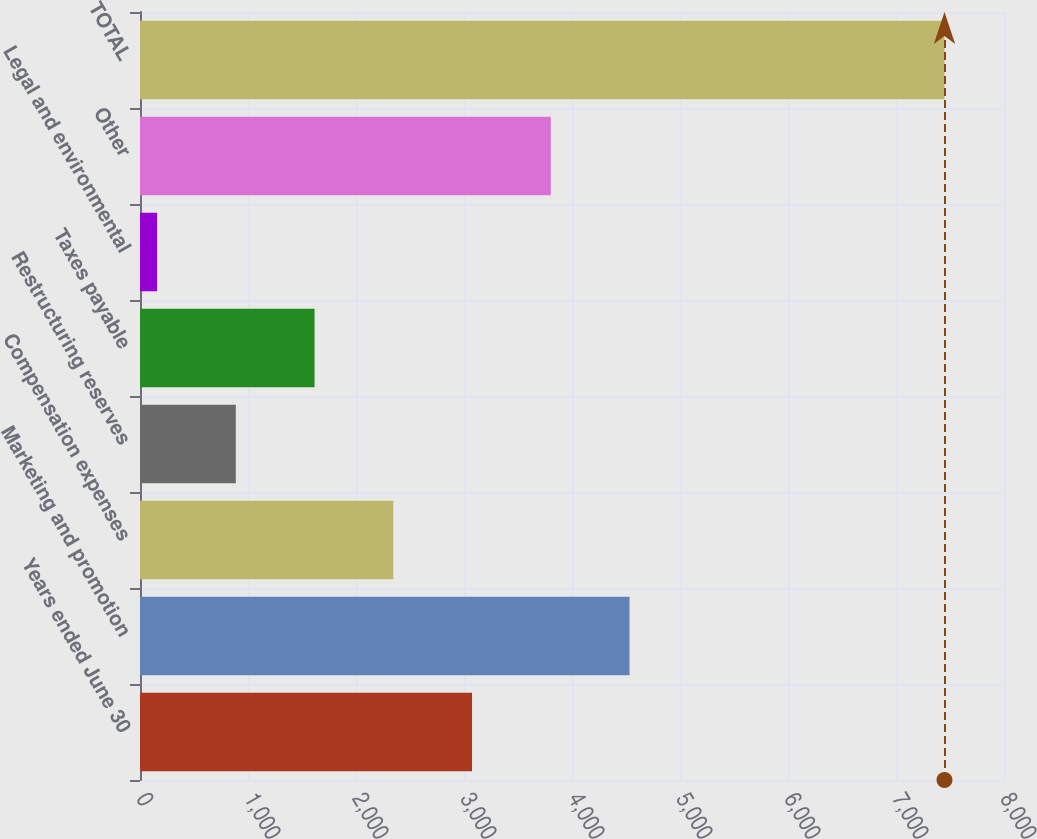<chart> <loc_0><loc_0><loc_500><loc_500><bar_chart><fcel>Years ended June 30<fcel>Marketing and promotion<fcel>Compensation expenses<fcel>Restructuring reserves<fcel>Taxes payable<fcel>Legal and environmental<fcel>Other<fcel>TOTAL<nl><fcel>3074.4<fcel>4532.6<fcel>2345.3<fcel>887.1<fcel>1616.2<fcel>158<fcel>3803.5<fcel>7449<nl></chart> 